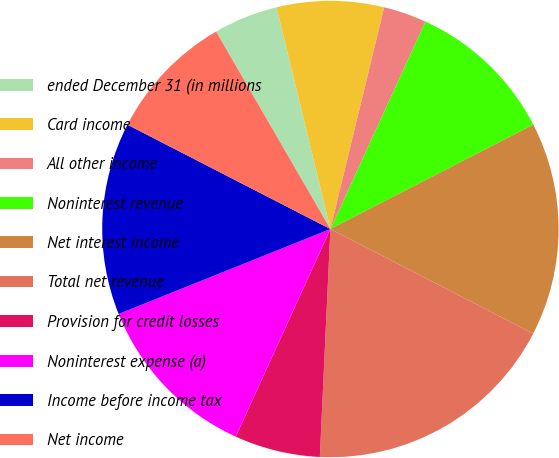Convert chart to OTSL. <chart><loc_0><loc_0><loc_500><loc_500><pie_chart><fcel>ended December 31 (in millions<fcel>Card income<fcel>All other income<fcel>Noninterest revenue<fcel>Net interest income<fcel>Total net revenue<fcel>Provision for credit losses<fcel>Noninterest expense (a)<fcel>Income before income tax<fcel>Net income<nl><fcel>4.56%<fcel>7.58%<fcel>3.05%<fcel>10.6%<fcel>15.14%<fcel>18.16%<fcel>6.07%<fcel>12.12%<fcel>13.63%<fcel>9.09%<nl></chart> 